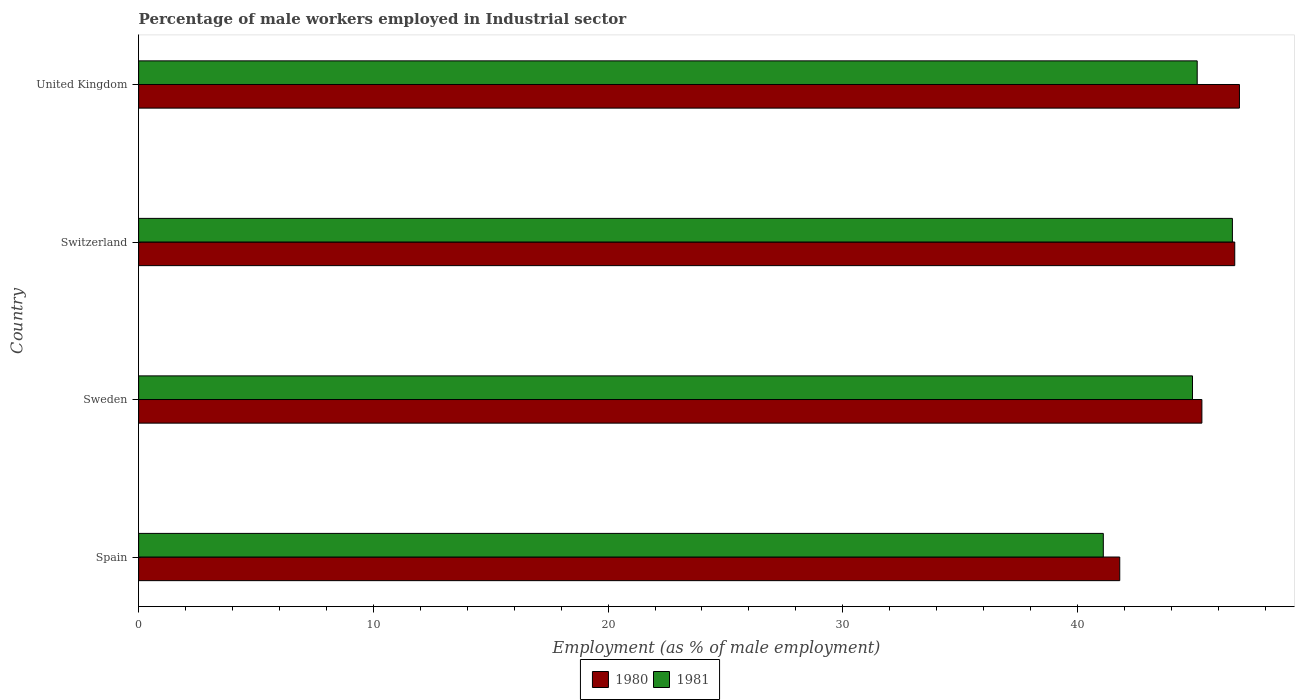How many groups of bars are there?
Ensure brevity in your answer.  4. In how many cases, is the number of bars for a given country not equal to the number of legend labels?
Provide a short and direct response. 0. What is the percentage of male workers employed in Industrial sector in 1981 in Sweden?
Provide a short and direct response. 44.9. Across all countries, what is the maximum percentage of male workers employed in Industrial sector in 1981?
Offer a terse response. 46.6. Across all countries, what is the minimum percentage of male workers employed in Industrial sector in 1980?
Your answer should be compact. 41.8. In which country was the percentage of male workers employed in Industrial sector in 1981 maximum?
Your response must be concise. Switzerland. What is the total percentage of male workers employed in Industrial sector in 1980 in the graph?
Provide a short and direct response. 180.7. What is the difference between the percentage of male workers employed in Industrial sector in 1981 in Sweden and that in Switzerland?
Make the answer very short. -1.7. What is the difference between the percentage of male workers employed in Industrial sector in 1981 in Switzerland and the percentage of male workers employed in Industrial sector in 1980 in United Kingdom?
Keep it short and to the point. -0.3. What is the average percentage of male workers employed in Industrial sector in 1980 per country?
Provide a succinct answer. 45.18. What is the difference between the percentage of male workers employed in Industrial sector in 1981 and percentage of male workers employed in Industrial sector in 1980 in Sweden?
Your answer should be very brief. -0.4. What is the ratio of the percentage of male workers employed in Industrial sector in 1981 in Spain to that in United Kingdom?
Your response must be concise. 0.91. Is the percentage of male workers employed in Industrial sector in 1981 in Sweden less than that in United Kingdom?
Give a very brief answer. Yes. What is the difference between the highest and the second highest percentage of male workers employed in Industrial sector in 1980?
Provide a short and direct response. 0.2. What is the difference between the highest and the lowest percentage of male workers employed in Industrial sector in 1981?
Offer a terse response. 5.5. How many bars are there?
Your response must be concise. 8. What is the difference between two consecutive major ticks on the X-axis?
Make the answer very short. 10. How many legend labels are there?
Your response must be concise. 2. How are the legend labels stacked?
Provide a short and direct response. Horizontal. What is the title of the graph?
Your response must be concise. Percentage of male workers employed in Industrial sector. What is the label or title of the X-axis?
Ensure brevity in your answer.  Employment (as % of male employment). What is the label or title of the Y-axis?
Your answer should be very brief. Country. What is the Employment (as % of male employment) of 1980 in Spain?
Keep it short and to the point. 41.8. What is the Employment (as % of male employment) in 1981 in Spain?
Your answer should be very brief. 41.1. What is the Employment (as % of male employment) of 1980 in Sweden?
Provide a short and direct response. 45.3. What is the Employment (as % of male employment) in 1981 in Sweden?
Provide a succinct answer. 44.9. What is the Employment (as % of male employment) of 1980 in Switzerland?
Provide a short and direct response. 46.7. What is the Employment (as % of male employment) of 1981 in Switzerland?
Your answer should be very brief. 46.6. What is the Employment (as % of male employment) in 1980 in United Kingdom?
Your answer should be compact. 46.9. What is the Employment (as % of male employment) in 1981 in United Kingdom?
Ensure brevity in your answer.  45.1. Across all countries, what is the maximum Employment (as % of male employment) of 1980?
Provide a short and direct response. 46.9. Across all countries, what is the maximum Employment (as % of male employment) in 1981?
Your response must be concise. 46.6. Across all countries, what is the minimum Employment (as % of male employment) in 1980?
Make the answer very short. 41.8. Across all countries, what is the minimum Employment (as % of male employment) in 1981?
Your answer should be compact. 41.1. What is the total Employment (as % of male employment) of 1980 in the graph?
Offer a very short reply. 180.7. What is the total Employment (as % of male employment) in 1981 in the graph?
Your answer should be compact. 177.7. What is the difference between the Employment (as % of male employment) of 1981 in Spain and that in Sweden?
Ensure brevity in your answer.  -3.8. What is the difference between the Employment (as % of male employment) of 1980 in Spain and that in Switzerland?
Give a very brief answer. -4.9. What is the difference between the Employment (as % of male employment) of 1980 in Spain and that in United Kingdom?
Make the answer very short. -5.1. What is the difference between the Employment (as % of male employment) of 1980 in Sweden and that in Switzerland?
Your response must be concise. -1.4. What is the difference between the Employment (as % of male employment) of 1981 in Sweden and that in Switzerland?
Offer a terse response. -1.7. What is the difference between the Employment (as % of male employment) of 1980 in Sweden and that in United Kingdom?
Offer a very short reply. -1.6. What is the difference between the Employment (as % of male employment) of 1980 in Spain and the Employment (as % of male employment) of 1981 in United Kingdom?
Provide a succinct answer. -3.3. What is the difference between the Employment (as % of male employment) of 1980 in Sweden and the Employment (as % of male employment) of 1981 in United Kingdom?
Ensure brevity in your answer.  0.2. What is the difference between the Employment (as % of male employment) of 1980 in Switzerland and the Employment (as % of male employment) of 1981 in United Kingdom?
Offer a terse response. 1.6. What is the average Employment (as % of male employment) of 1980 per country?
Keep it short and to the point. 45.17. What is the average Employment (as % of male employment) of 1981 per country?
Give a very brief answer. 44.42. What is the difference between the Employment (as % of male employment) in 1980 and Employment (as % of male employment) in 1981 in Switzerland?
Your response must be concise. 0.1. What is the ratio of the Employment (as % of male employment) of 1980 in Spain to that in Sweden?
Make the answer very short. 0.92. What is the ratio of the Employment (as % of male employment) in 1981 in Spain to that in Sweden?
Your response must be concise. 0.92. What is the ratio of the Employment (as % of male employment) of 1980 in Spain to that in Switzerland?
Your response must be concise. 0.9. What is the ratio of the Employment (as % of male employment) of 1981 in Spain to that in Switzerland?
Your answer should be compact. 0.88. What is the ratio of the Employment (as % of male employment) in 1980 in Spain to that in United Kingdom?
Provide a succinct answer. 0.89. What is the ratio of the Employment (as % of male employment) of 1981 in Spain to that in United Kingdom?
Offer a terse response. 0.91. What is the ratio of the Employment (as % of male employment) in 1981 in Sweden to that in Switzerland?
Ensure brevity in your answer.  0.96. What is the ratio of the Employment (as % of male employment) of 1980 in Sweden to that in United Kingdom?
Make the answer very short. 0.97. What is the ratio of the Employment (as % of male employment) in 1981 in Sweden to that in United Kingdom?
Keep it short and to the point. 1. What is the ratio of the Employment (as % of male employment) of 1980 in Switzerland to that in United Kingdom?
Your answer should be compact. 1. What is the difference between the highest and the second highest Employment (as % of male employment) of 1980?
Your response must be concise. 0.2. 